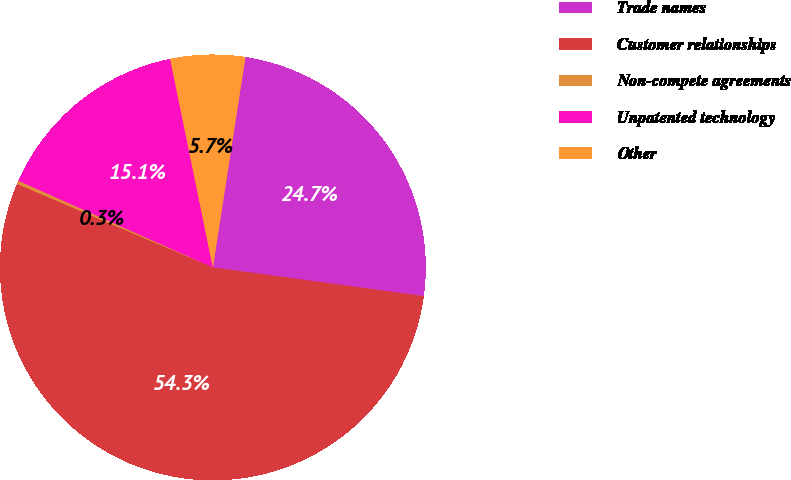Convert chart. <chart><loc_0><loc_0><loc_500><loc_500><pie_chart><fcel>Trade names<fcel>Customer relationships<fcel>Non-compete agreements<fcel>Unpatented technology<fcel>Other<nl><fcel>24.71%<fcel>54.26%<fcel>0.26%<fcel>15.11%<fcel>5.66%<nl></chart> 